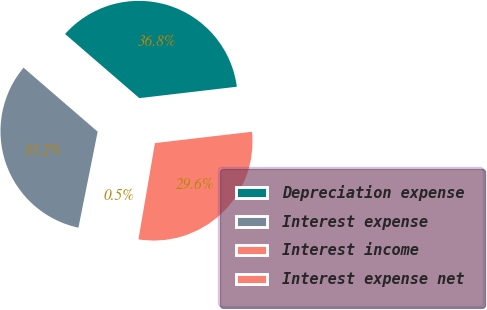Convert chart. <chart><loc_0><loc_0><loc_500><loc_500><pie_chart><fcel>Depreciation expense<fcel>Interest expense<fcel>Interest income<fcel>Interest expense net<nl><fcel>36.81%<fcel>33.18%<fcel>0.45%<fcel>29.55%<nl></chart> 